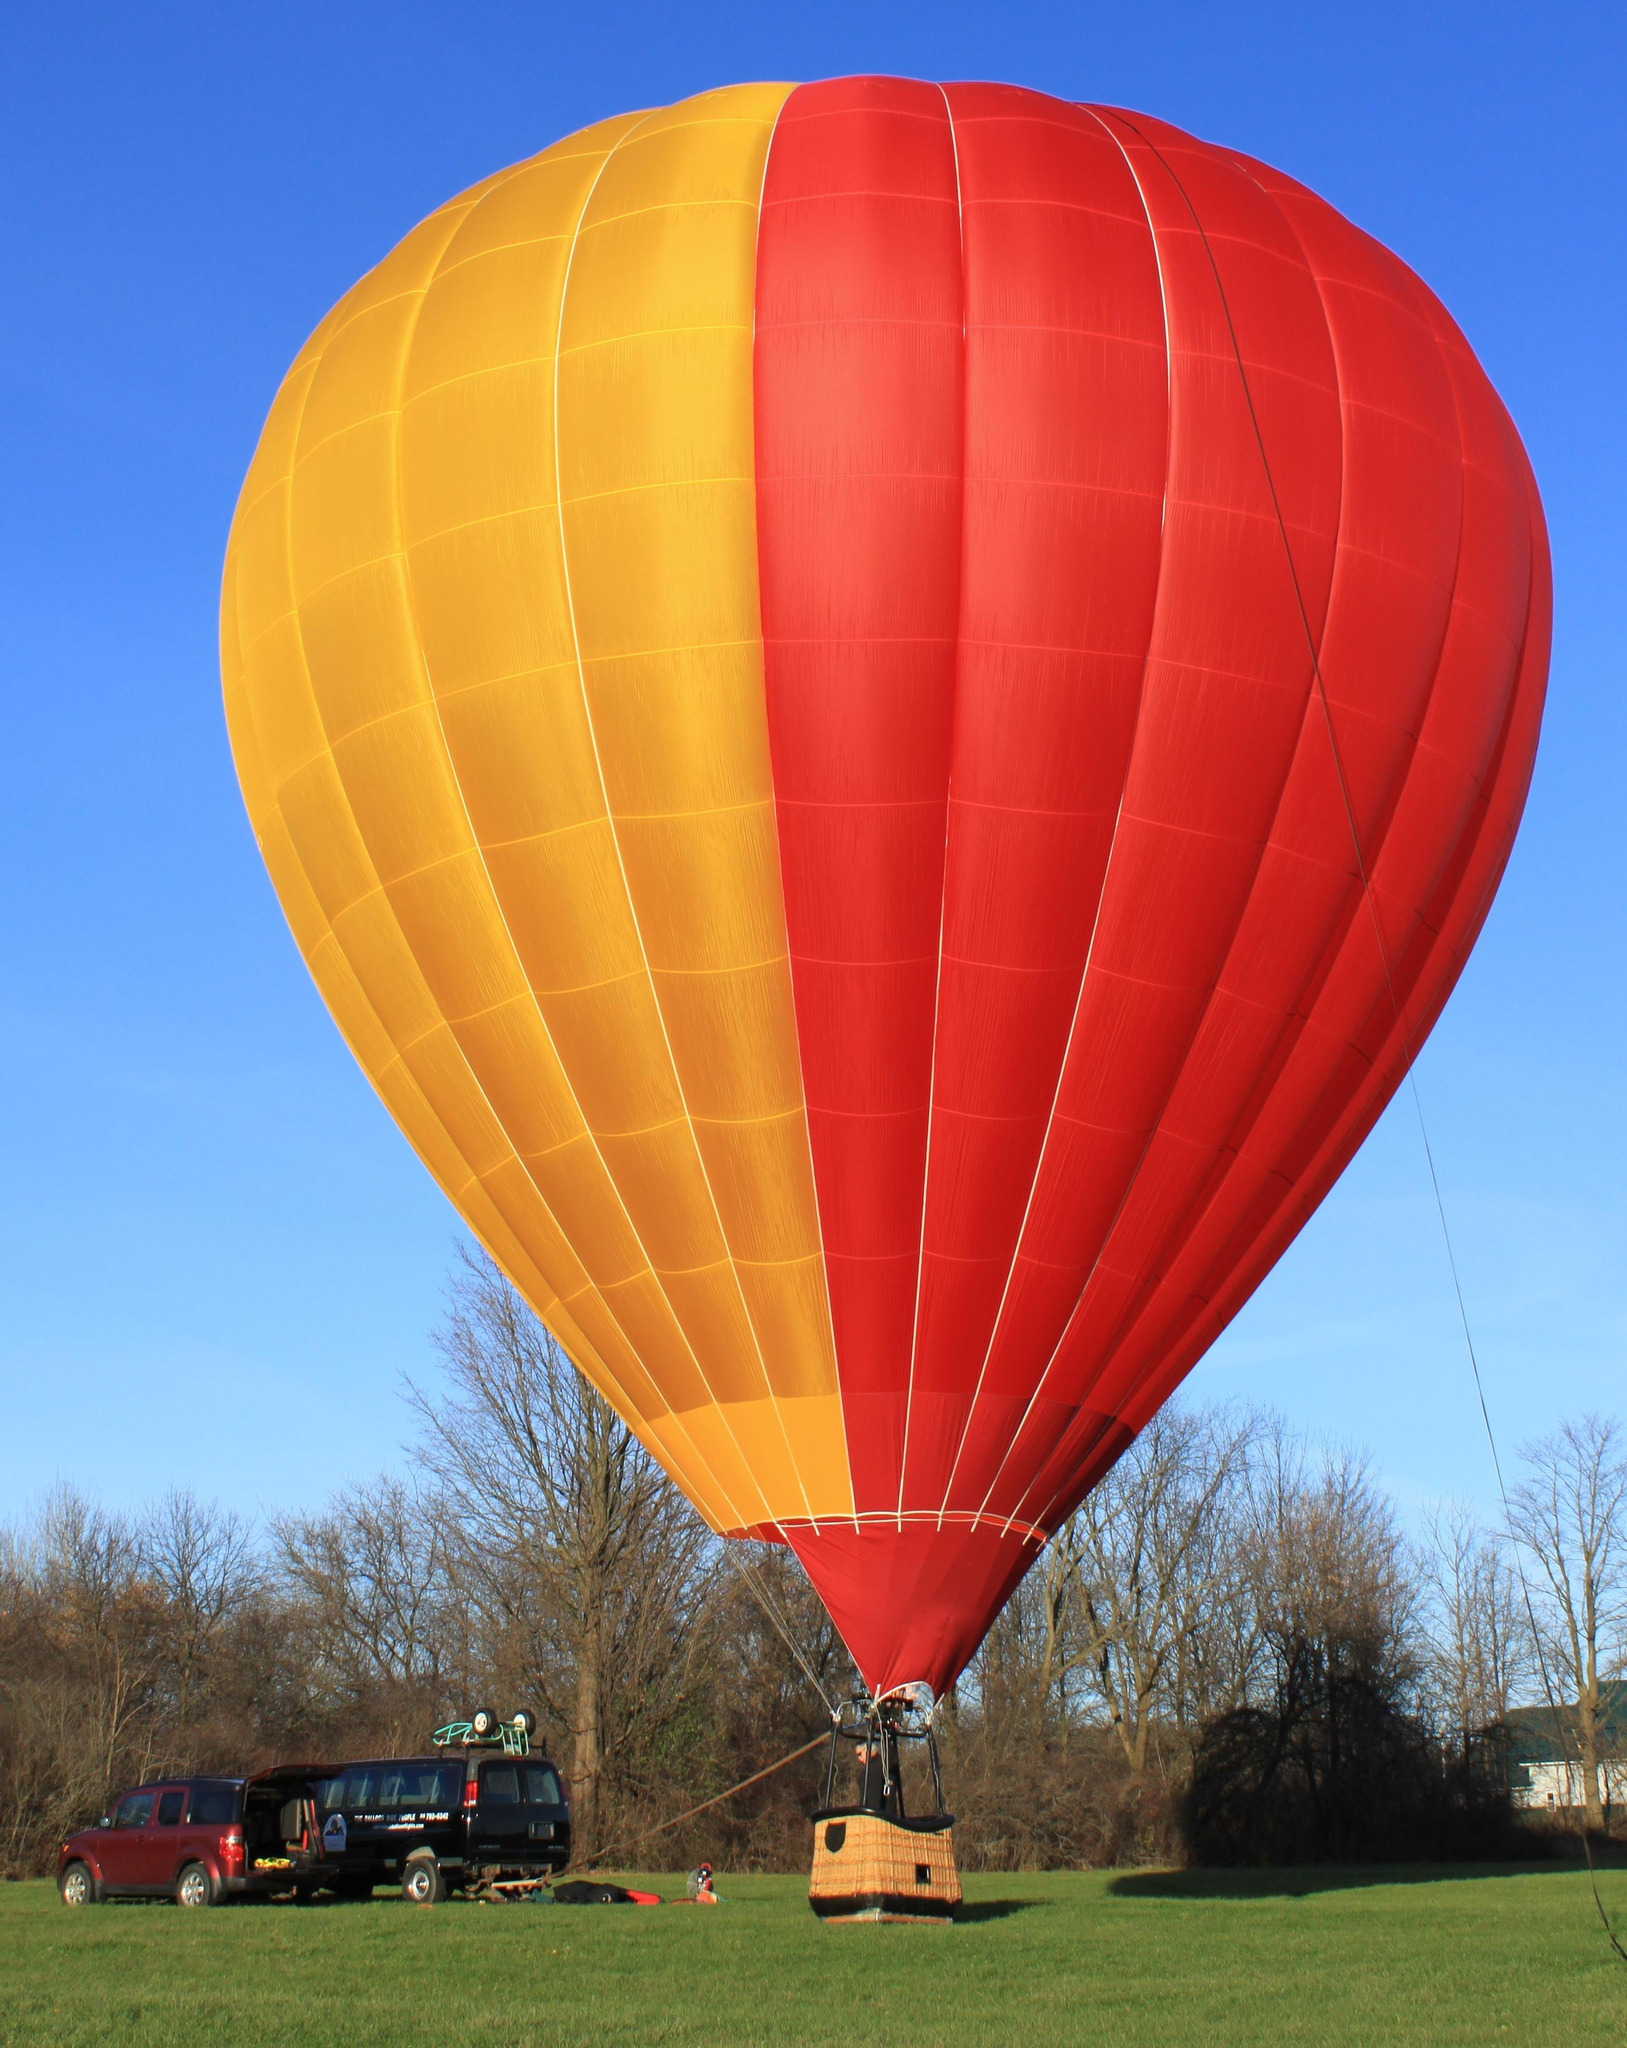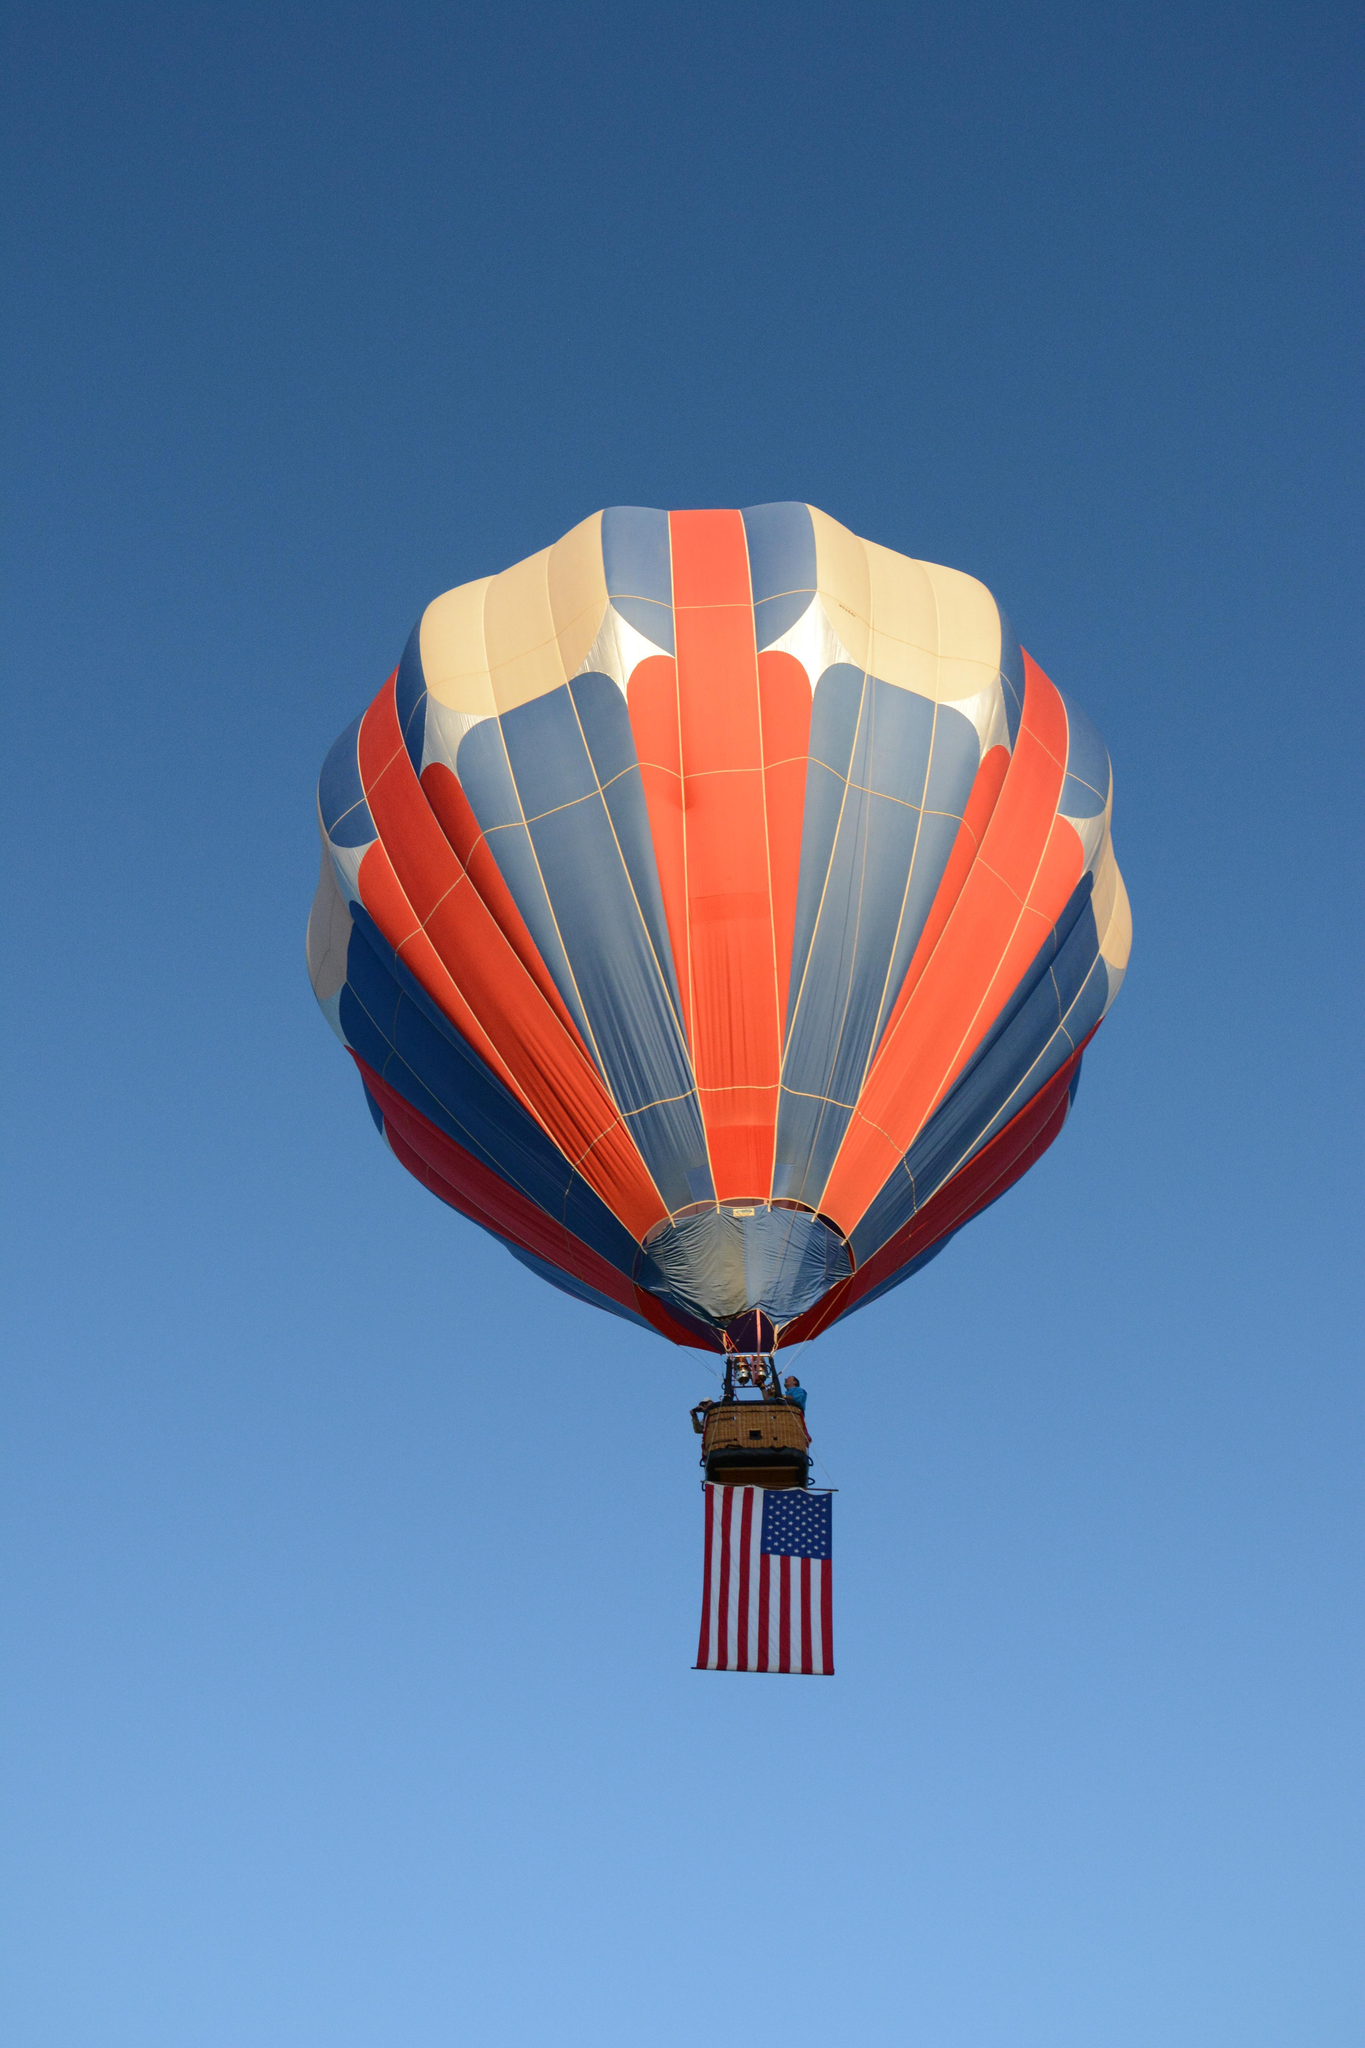The first image is the image on the left, the second image is the image on the right. Assess this claim about the two images: "An image shows at least part of a person completely outside the balloon, in midair.". Correct or not? Answer yes or no. No. 